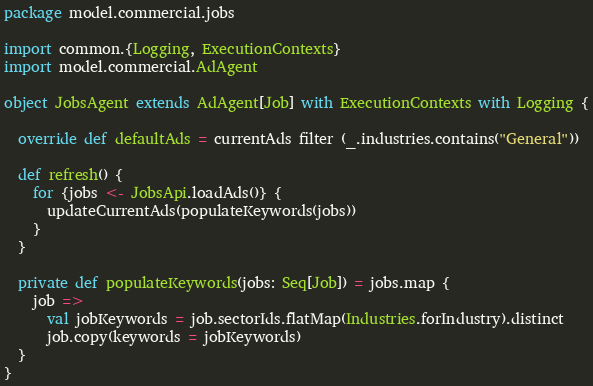Convert code to text. <code><loc_0><loc_0><loc_500><loc_500><_Scala_>package model.commercial.jobs

import common.{Logging, ExecutionContexts}
import model.commercial.AdAgent

object JobsAgent extends AdAgent[Job] with ExecutionContexts with Logging {

  override def defaultAds = currentAds filter (_.industries.contains("General"))

  def refresh() {
    for {jobs <- JobsApi.loadAds()} {
      updateCurrentAds(populateKeywords(jobs))
    }
  }

  private def populateKeywords(jobs: Seq[Job]) = jobs.map {
    job =>
      val jobKeywords = job.sectorIds.flatMap(Industries.forIndustry).distinct
      job.copy(keywords = jobKeywords)
  }
}
</code> 